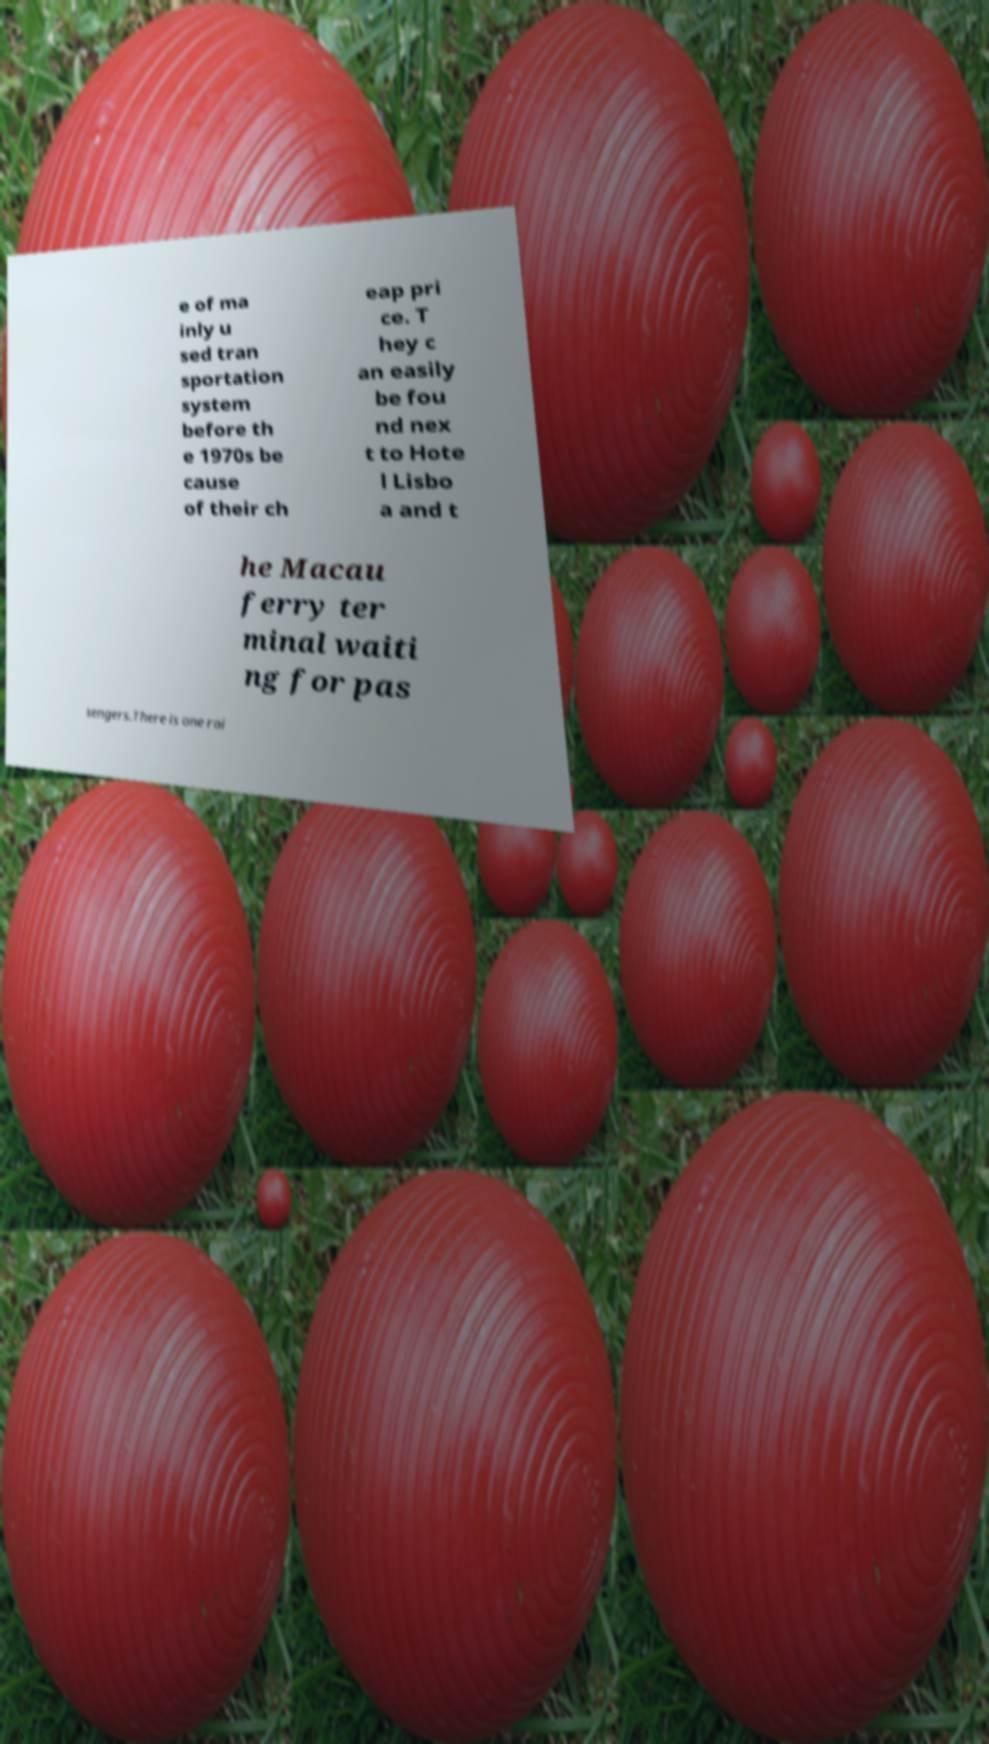For documentation purposes, I need the text within this image transcribed. Could you provide that? e of ma inly u sed tran sportation system before th e 1970s be cause of their ch eap pri ce. T hey c an easily be fou nd nex t to Hote l Lisbo a and t he Macau ferry ter minal waiti ng for pas sengers.There is one rai 